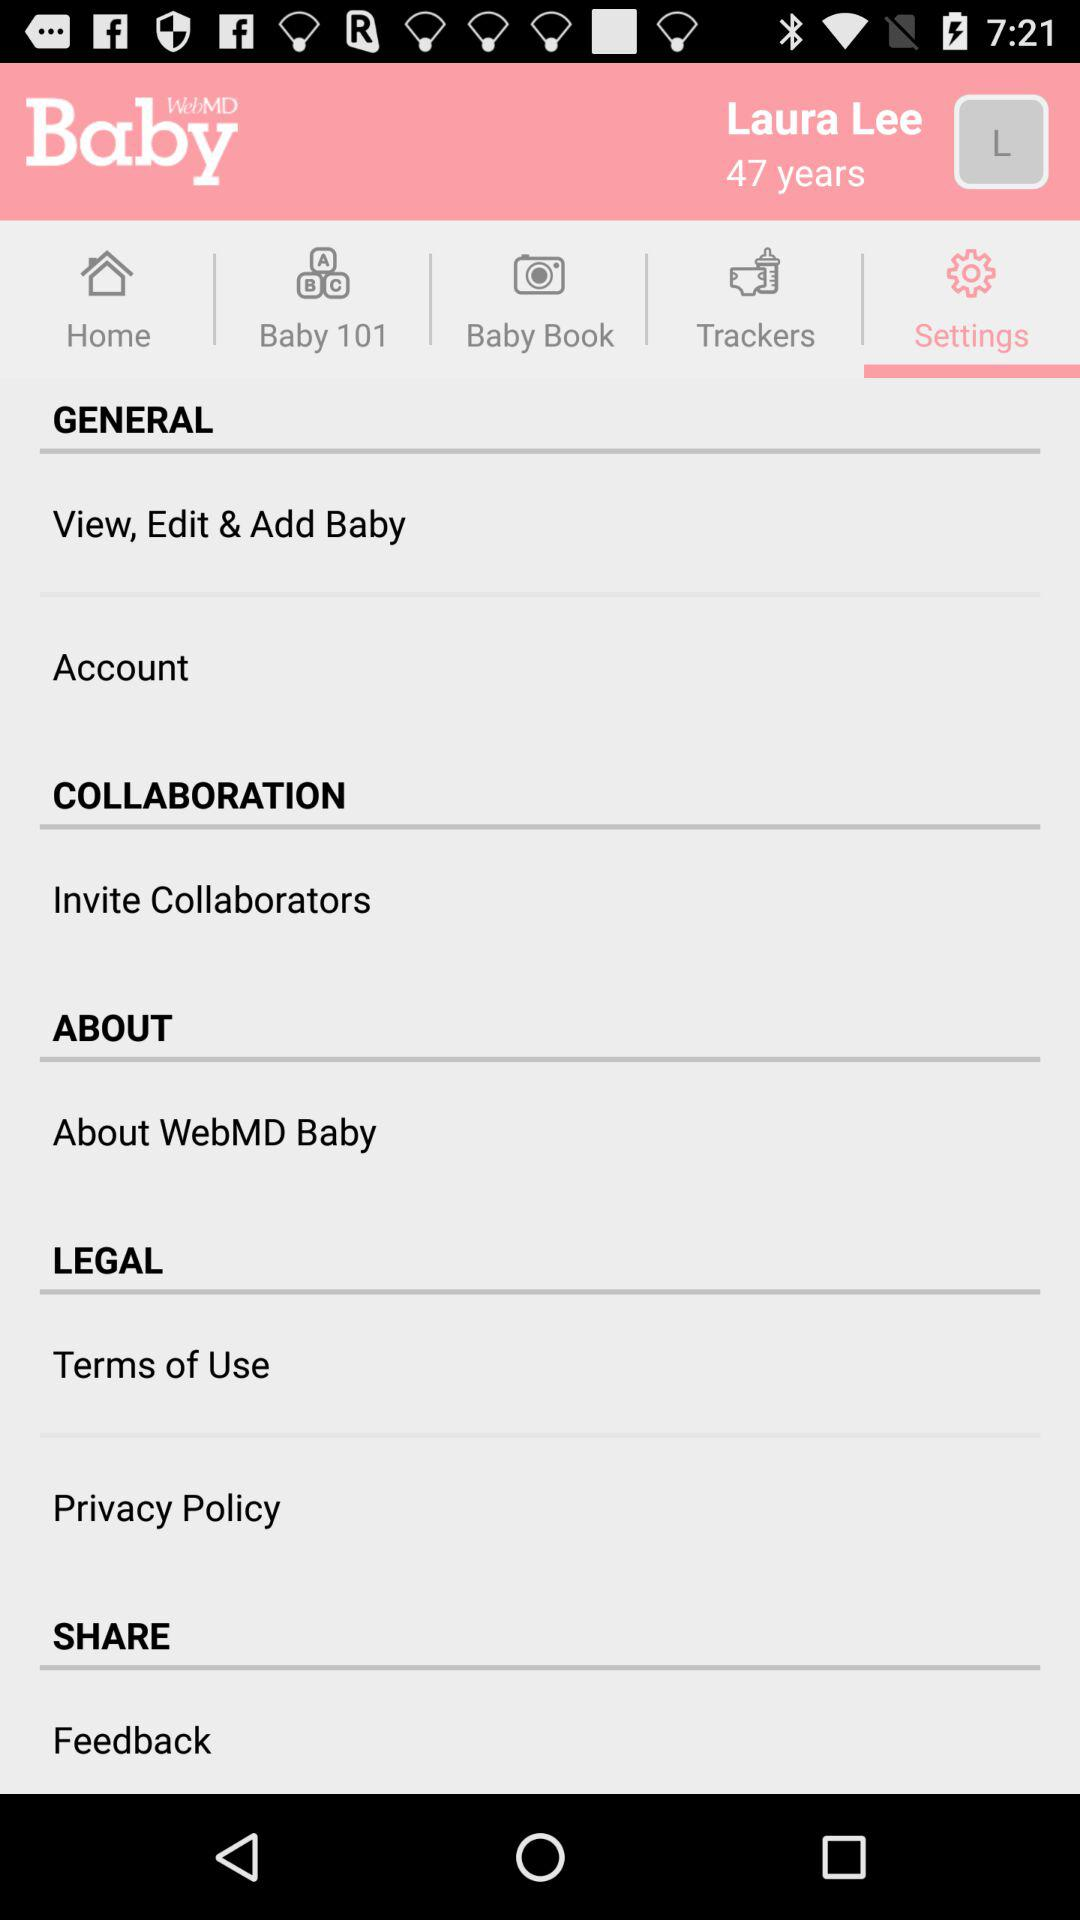What user name is used? The used user name is Laura Lee. 